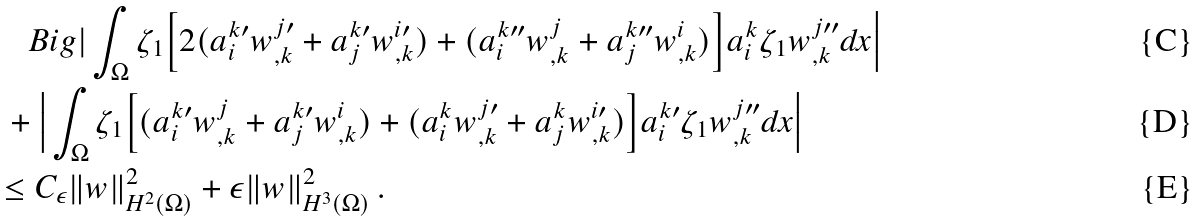<formula> <loc_0><loc_0><loc_500><loc_500>& \quad B i g | \int _ { \Omega } \zeta _ { 1 } \Big [ 2 ( a _ { i } ^ { k \prime } w _ { , k } ^ { j \prime } + a _ { j } ^ { k \prime } w _ { , k } ^ { i \prime } ) + ( a _ { i } ^ { k \prime \prime } w _ { , k } ^ { j } + a _ { j } ^ { k \prime \prime } w ^ { i } _ { , k } ) \Big ] a _ { i } ^ { k } \zeta _ { 1 } w _ { , k } ^ { j \prime \prime } d x \Big | \\ & \ + \Big | \int _ { \Omega } \zeta _ { 1 } \Big [ ( a _ { i } ^ { k \prime } w ^ { j } _ { , k } + a _ { j } ^ { k \prime } w ^ { i } _ { , k } ) + ( a _ { i } ^ { k } w _ { , k } ^ { j \prime } + a _ { j } ^ { k } w _ { , k } ^ { i \prime } ) \Big ] a _ { i } ^ { k \prime } \zeta _ { 1 } w _ { , k } ^ { j \prime \prime } d x \Big | \\ & \leq C _ { \epsilon } \| w \| ^ { 2 } _ { H ^ { 2 } ( \Omega ) } + \epsilon \| w \| ^ { 2 } _ { H ^ { 3 } ( \Omega ) } \, .</formula> 